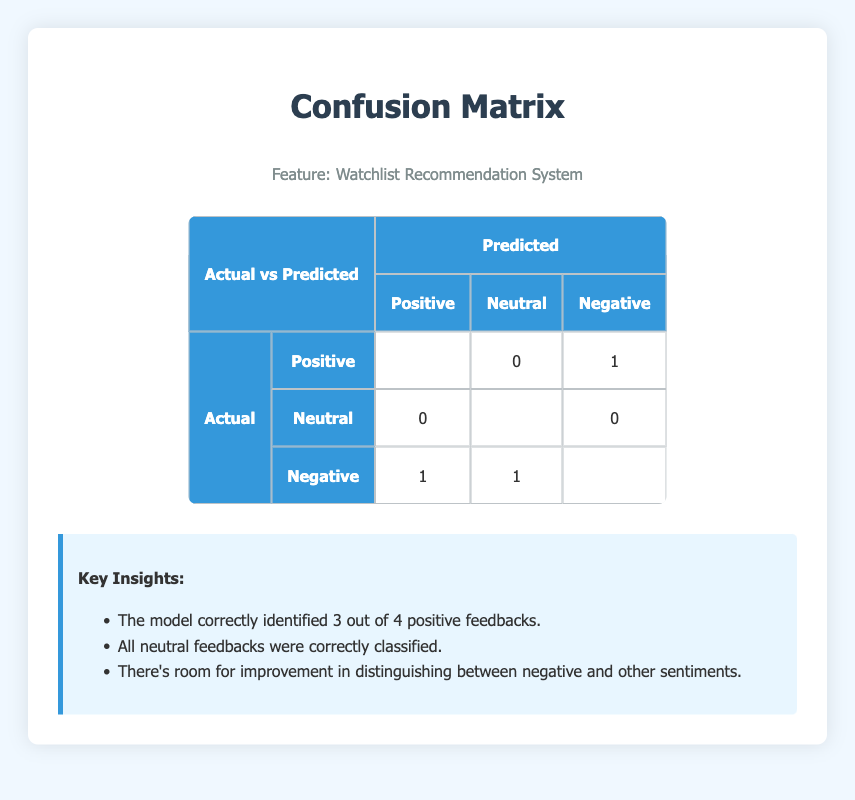What is the total number of actual positive labels? To find the total number of actual positive labels, we look at the row marked "Positive" in the "Actual" column. There are 4 instances of positive feedback in total.
Answer: 4 How many negative feedbacks were predicted as positive? In the "Negative" row under "Actual," there is 1 cell that shows the predicted label as "Positive." This indicates 1 instance of negative feedback mistakenly classified as positive.
Answer: 1 What is the total number of predicted neutral feedbacks? To find the total number of predictions for the neutral feedbacks, we check the "Neutral" column under "Predicted." There are 2 instances labeled as neutral.
Answer: 2 Did the model correctly classify all neutral feedback? Yes, all neutral feedback received correct predictions, as indicated in the table where both instances are highlighted under "Neutral" for "Predicted."
Answer: Yes What is the difference between actual positives and those predicted as negatives? The actual positives total 4, and 1 of those was predicted as negative. So, we calculate 4 - 1 = 3. The difference is 3.
Answer: 3 How many instances of negative feedback were correctly identified? To find the correctly identified negative feedback, we look at the "Negative" row under "Actual" and check for the predicted label as "Negative." There are 2 cases correctly identified.
Answer: 2 What percentage of total feedbacks were classified as positive? The total number of feedback instances is 10. Out of these, 3 were classified as positive. The percentage is calculated as (3/10) * 100 = 30%.
Answer: 30% What are the chances of a neutral feedback being misclassified as negative? From the table, 0 neutral feedback instances were misclassified as negative out of 2 total neutral feedbacks. Thus, 0 out of 2 means 0% chance.
Answer: 0% How many total instances of feedback were there? By looking at the rows, we see there are 10 total feedback instances represented on the table.
Answer: 10 